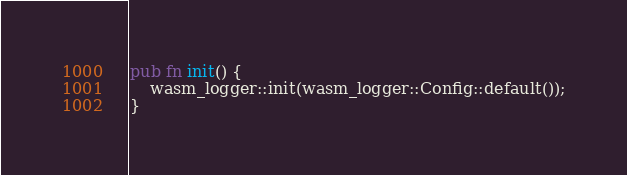Convert code to text. <code><loc_0><loc_0><loc_500><loc_500><_Rust_>pub fn init() {
    wasm_logger::init(wasm_logger::Config::default());
}
</code> 